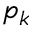<formula> <loc_0><loc_0><loc_500><loc_500>p _ { k }</formula> 